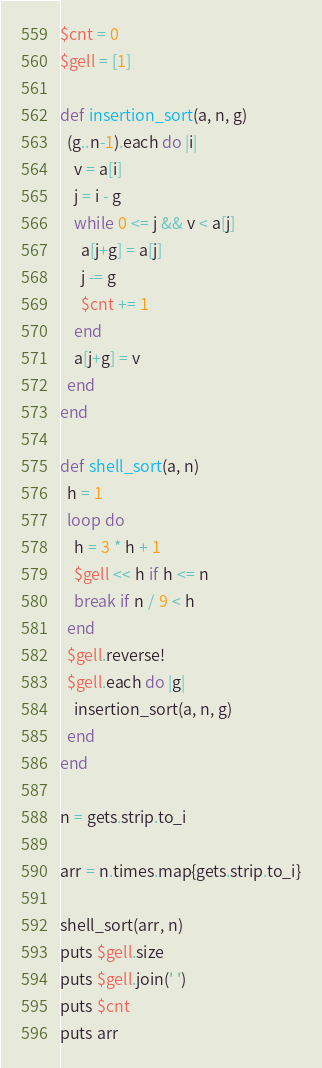<code> <loc_0><loc_0><loc_500><loc_500><_Ruby_>$cnt = 0
$gell = [1]

def insertion_sort(a, n, g)
  (g..n-1).each do |i|
    v = a[i]
    j = i - g
    while 0 <= j && v < a[j]
      a[j+g] = a[j]
      j -= g
      $cnt += 1
    end
    a[j+g] = v
  end
end

def shell_sort(a, n)
  h = 1
  loop do
    h = 3 * h + 1
    $gell << h if h <= n
    break if n / 9 < h
  end
  $gell.reverse!
  $gell.each do |g|
    insertion_sort(a, n, g)
  end
end

n = gets.strip.to_i

arr = n.times.map{gets.strip.to_i}

shell_sort(arr, n)
puts $gell.size
puts $gell.join(' ')
puts $cnt
puts arr</code> 